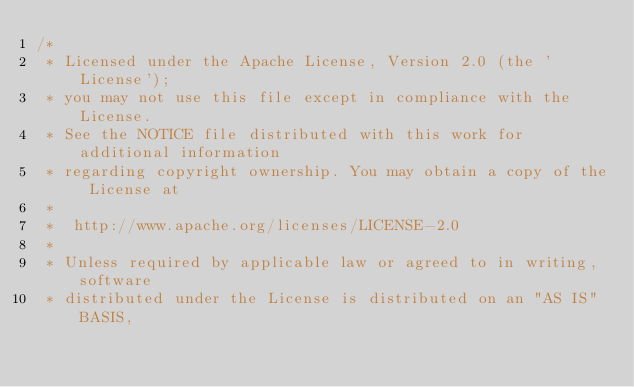<code> <loc_0><loc_0><loc_500><loc_500><_C++_>/*
 * Licensed under the Apache License, Version 2.0 (the 'License');
 * you may not use this file except in compliance with the License.
 * See the NOTICE file distributed with this work for additional information
 * regarding copyright ownership. You may obtain a copy of the License at
 *
 *  http://www.apache.org/licenses/LICENSE-2.0
 *
 * Unless required by applicable law or agreed to in writing, software
 * distributed under the License is distributed on an "AS IS" BASIS,</code> 